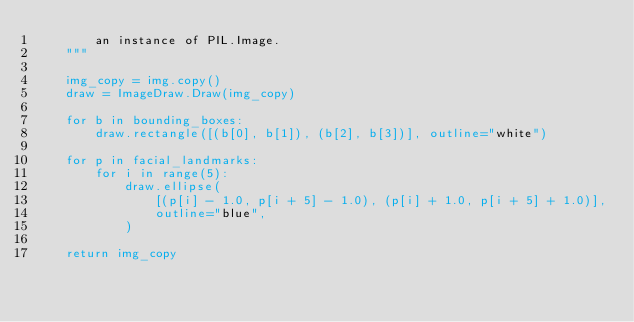Convert code to text. <code><loc_0><loc_0><loc_500><loc_500><_Python_>        an instance of PIL.Image.
    """

    img_copy = img.copy()
    draw = ImageDraw.Draw(img_copy)

    for b in bounding_boxes:
        draw.rectangle([(b[0], b[1]), (b[2], b[3])], outline="white")

    for p in facial_landmarks:
        for i in range(5):
            draw.ellipse(
                [(p[i] - 1.0, p[i + 5] - 1.0), (p[i] + 1.0, p[i + 5] + 1.0)],
                outline="blue",
            )

    return img_copy
</code> 